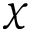<formula> <loc_0><loc_0><loc_500><loc_500>\chi</formula> 